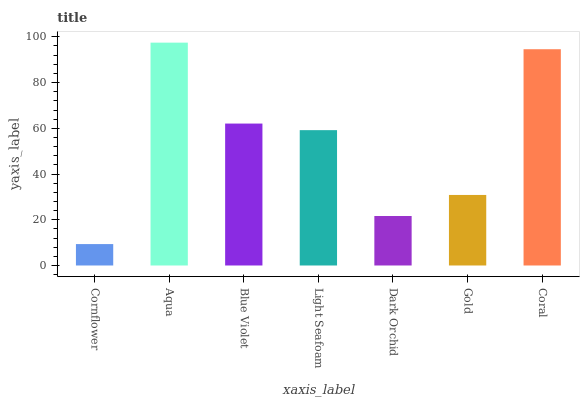Is Cornflower the minimum?
Answer yes or no. Yes. Is Aqua the maximum?
Answer yes or no. Yes. Is Blue Violet the minimum?
Answer yes or no. No. Is Blue Violet the maximum?
Answer yes or no. No. Is Aqua greater than Blue Violet?
Answer yes or no. Yes. Is Blue Violet less than Aqua?
Answer yes or no. Yes. Is Blue Violet greater than Aqua?
Answer yes or no. No. Is Aqua less than Blue Violet?
Answer yes or no. No. Is Light Seafoam the high median?
Answer yes or no. Yes. Is Light Seafoam the low median?
Answer yes or no. Yes. Is Blue Violet the high median?
Answer yes or no. No. Is Gold the low median?
Answer yes or no. No. 